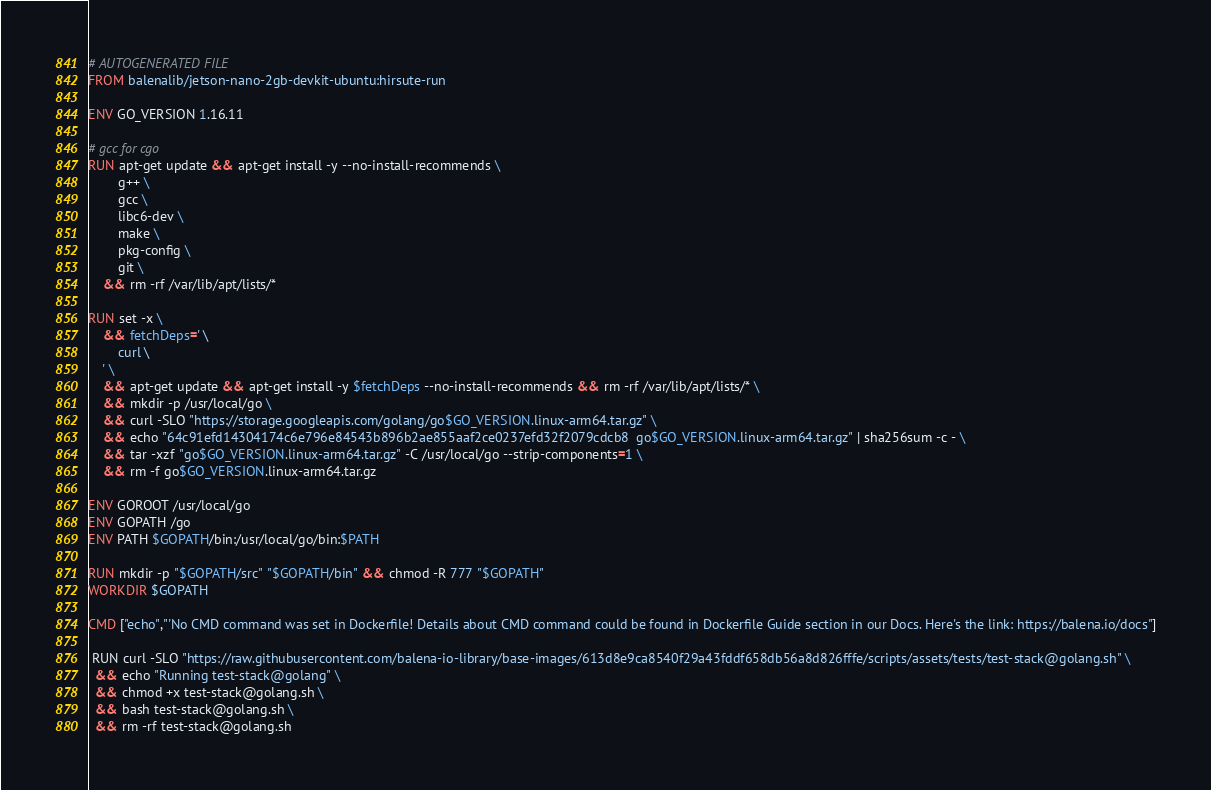Convert code to text. <code><loc_0><loc_0><loc_500><loc_500><_Dockerfile_># AUTOGENERATED FILE
FROM balenalib/jetson-nano-2gb-devkit-ubuntu:hirsute-run

ENV GO_VERSION 1.16.11

# gcc for cgo
RUN apt-get update && apt-get install -y --no-install-recommends \
		g++ \
		gcc \
		libc6-dev \
		make \
		pkg-config \
		git \
	&& rm -rf /var/lib/apt/lists/*

RUN set -x \
	&& fetchDeps=' \
		curl \
	' \
	&& apt-get update && apt-get install -y $fetchDeps --no-install-recommends && rm -rf /var/lib/apt/lists/* \
	&& mkdir -p /usr/local/go \
	&& curl -SLO "https://storage.googleapis.com/golang/go$GO_VERSION.linux-arm64.tar.gz" \
	&& echo "64c91efd14304174c6e796e84543b896b2ae855aaf2ce0237efd32f2079cdcb8  go$GO_VERSION.linux-arm64.tar.gz" | sha256sum -c - \
	&& tar -xzf "go$GO_VERSION.linux-arm64.tar.gz" -C /usr/local/go --strip-components=1 \
	&& rm -f go$GO_VERSION.linux-arm64.tar.gz

ENV GOROOT /usr/local/go
ENV GOPATH /go
ENV PATH $GOPATH/bin:/usr/local/go/bin:$PATH

RUN mkdir -p "$GOPATH/src" "$GOPATH/bin" && chmod -R 777 "$GOPATH"
WORKDIR $GOPATH

CMD ["echo","'No CMD command was set in Dockerfile! Details about CMD command could be found in Dockerfile Guide section in our Docs. Here's the link: https://balena.io/docs"]

 RUN curl -SLO "https://raw.githubusercontent.com/balena-io-library/base-images/613d8e9ca8540f29a43fddf658db56a8d826fffe/scripts/assets/tests/test-stack@golang.sh" \
  && echo "Running test-stack@golang" \
  && chmod +x test-stack@golang.sh \
  && bash test-stack@golang.sh \
  && rm -rf test-stack@golang.sh 
</code> 